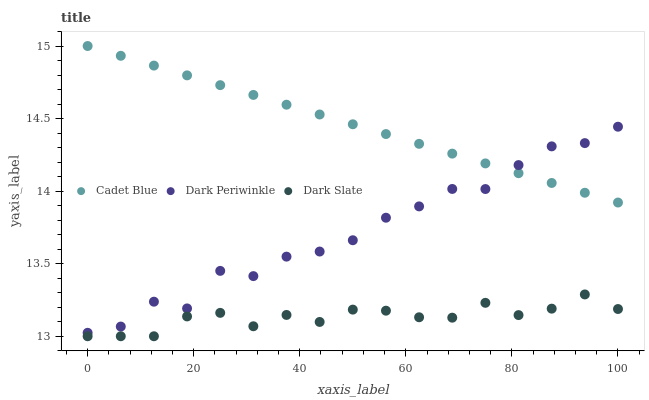Does Dark Slate have the minimum area under the curve?
Answer yes or no. Yes. Does Cadet Blue have the maximum area under the curve?
Answer yes or no. Yes. Does Dark Periwinkle have the minimum area under the curve?
Answer yes or no. No. Does Dark Periwinkle have the maximum area under the curve?
Answer yes or no. No. Is Cadet Blue the smoothest?
Answer yes or no. Yes. Is Dark Periwinkle the roughest?
Answer yes or no. Yes. Is Dark Periwinkle the smoothest?
Answer yes or no. No. Is Cadet Blue the roughest?
Answer yes or no. No. Does Dark Slate have the lowest value?
Answer yes or no. Yes. Does Dark Periwinkle have the lowest value?
Answer yes or no. No. Does Cadet Blue have the highest value?
Answer yes or no. Yes. Does Dark Periwinkle have the highest value?
Answer yes or no. No. Is Dark Slate less than Dark Periwinkle?
Answer yes or no. Yes. Is Cadet Blue greater than Dark Slate?
Answer yes or no. Yes. Does Cadet Blue intersect Dark Periwinkle?
Answer yes or no. Yes. Is Cadet Blue less than Dark Periwinkle?
Answer yes or no. No. Is Cadet Blue greater than Dark Periwinkle?
Answer yes or no. No. Does Dark Slate intersect Dark Periwinkle?
Answer yes or no. No. 